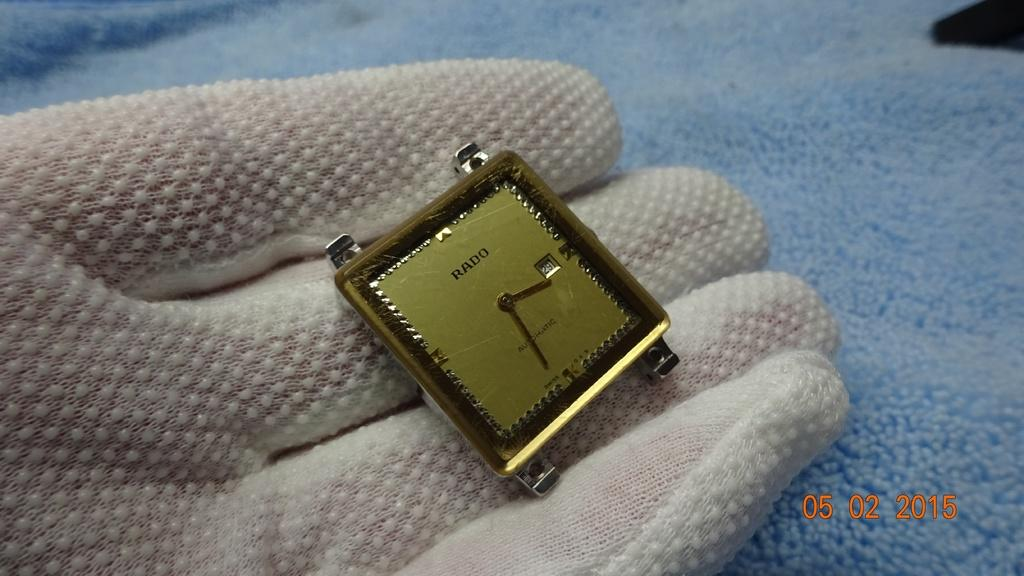<image>
Write a terse but informative summary of the picture. A beautiful Dial of the golden automatic watch from Rado Company 